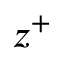Convert formula to latex. <formula><loc_0><loc_0><loc_500><loc_500>z ^ { + }</formula> 